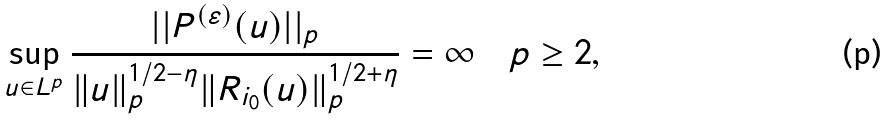Convert formula to latex. <formula><loc_0><loc_0><loc_500><loc_500>\sup _ { u \in L ^ { p } } \frac { | | P ^ { ( \varepsilon ) } ( u ) | | _ { p } } { \| u \| _ { p } ^ { 1 / 2 - \eta } \| R _ { i _ { 0 } } ( u ) \| _ { p } ^ { 1 / 2 + \eta } } = \infty \quad p \geq 2 ,</formula> 